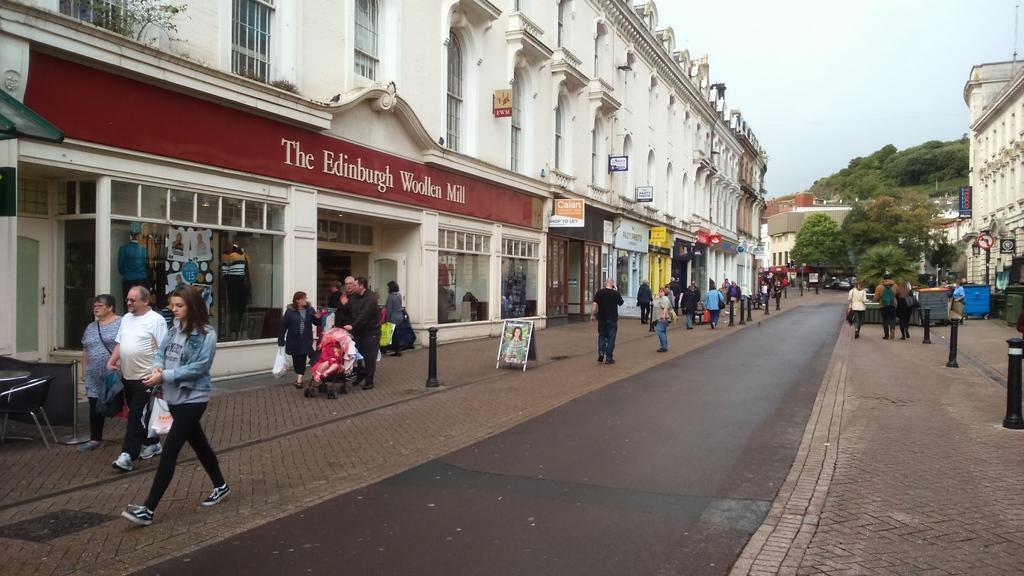How would you summarize this image in a sentence or two? There are groups of people walking. These are the buildings with the windows. This looks like a name board, which is attached to the building wall. I think this is a stroller with a baby sitting in it. On the left side of the image, that looks like a chair. These are the trees. This looks like a board, which is placed on the road. I think these are the lane poles. This is the road. Here is the sky. 